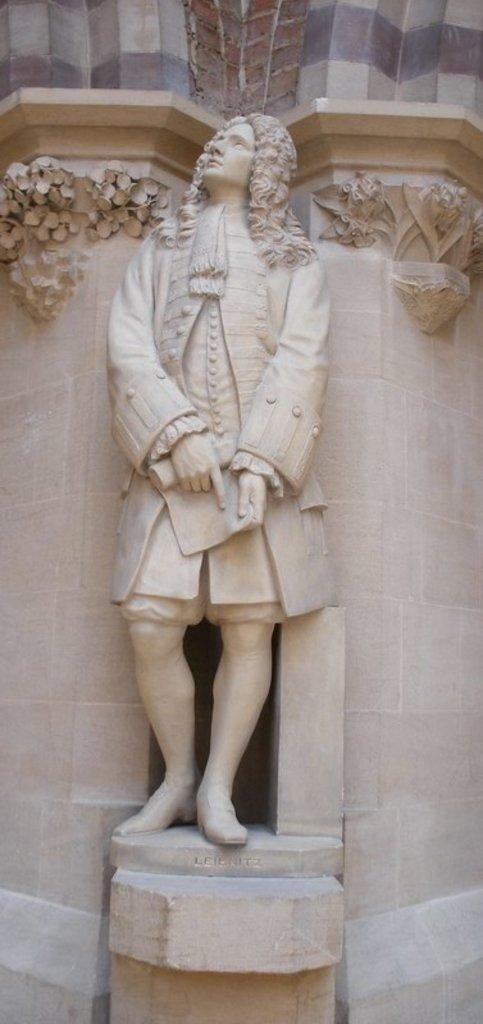What is the main subject of the sculpture in the image? The sculpture is of a man standing and holding a paper. What is the gender of the person depicted in the sculpture? The sculpture is of a man. What is the man holding in the sculpture? The man is holding a paper. What architectural elements can be seen in the image? There are pillars in the image. What design is carved on the pillars? The pillars have a specific design carved on them. What type of house can be seen in the alley behind the sculpture? There is no house or alley present in the image; it only features a sculpture and pillars. 